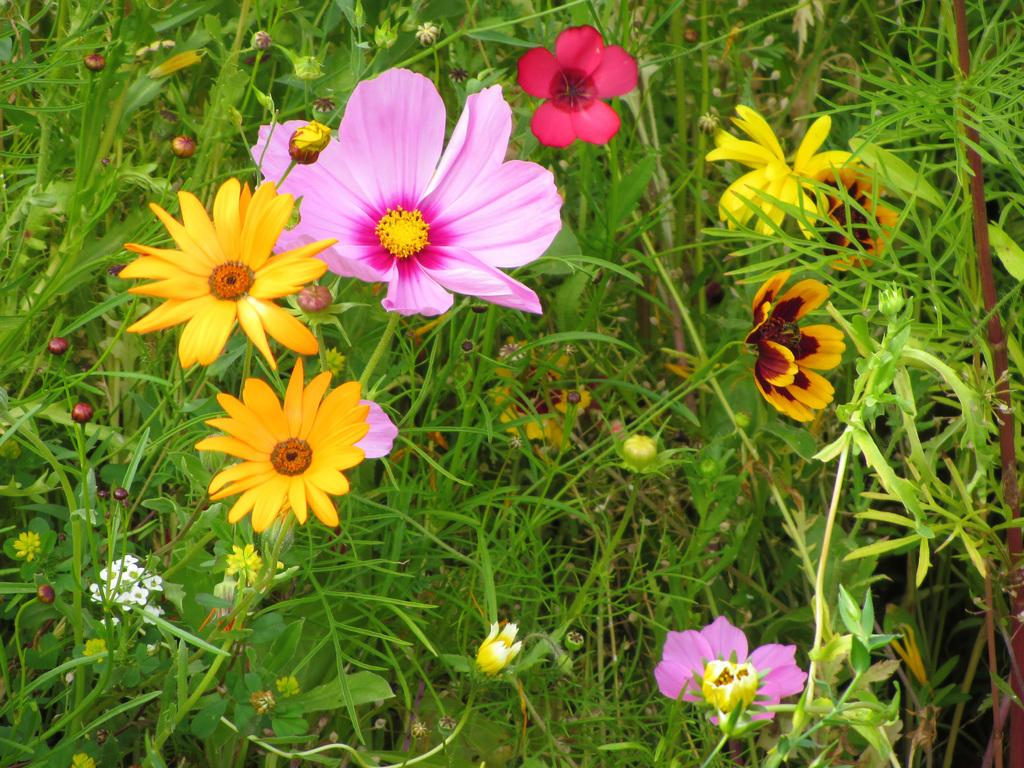What type of living organisms are present in the image? There are plants in the image. What specific features can be observed on the plants? The plants have leaves, flowers of different colors, and buds. What type of shoes are the plants wearing in the image? There are no shoes present in the image, as plants do not wear shoes. 